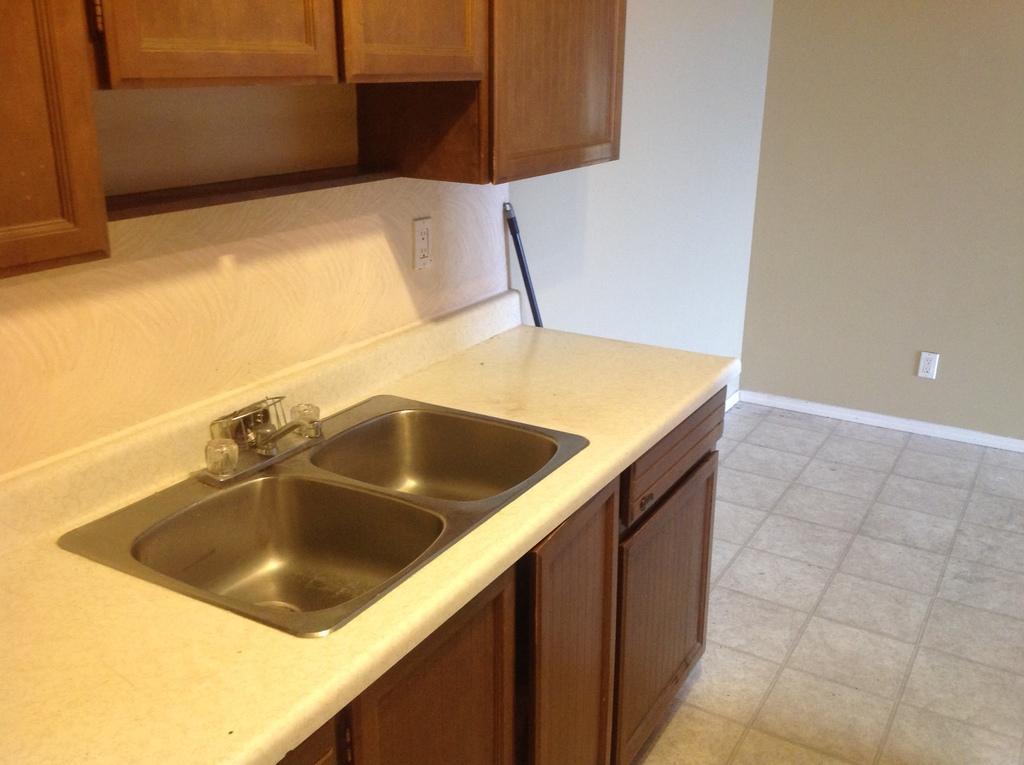Please provide a concise description of this image. In this image, we can see some sinks and a tap. We can see the ground and the wall with some objects. We can also see some cupboards and a black colored object. 